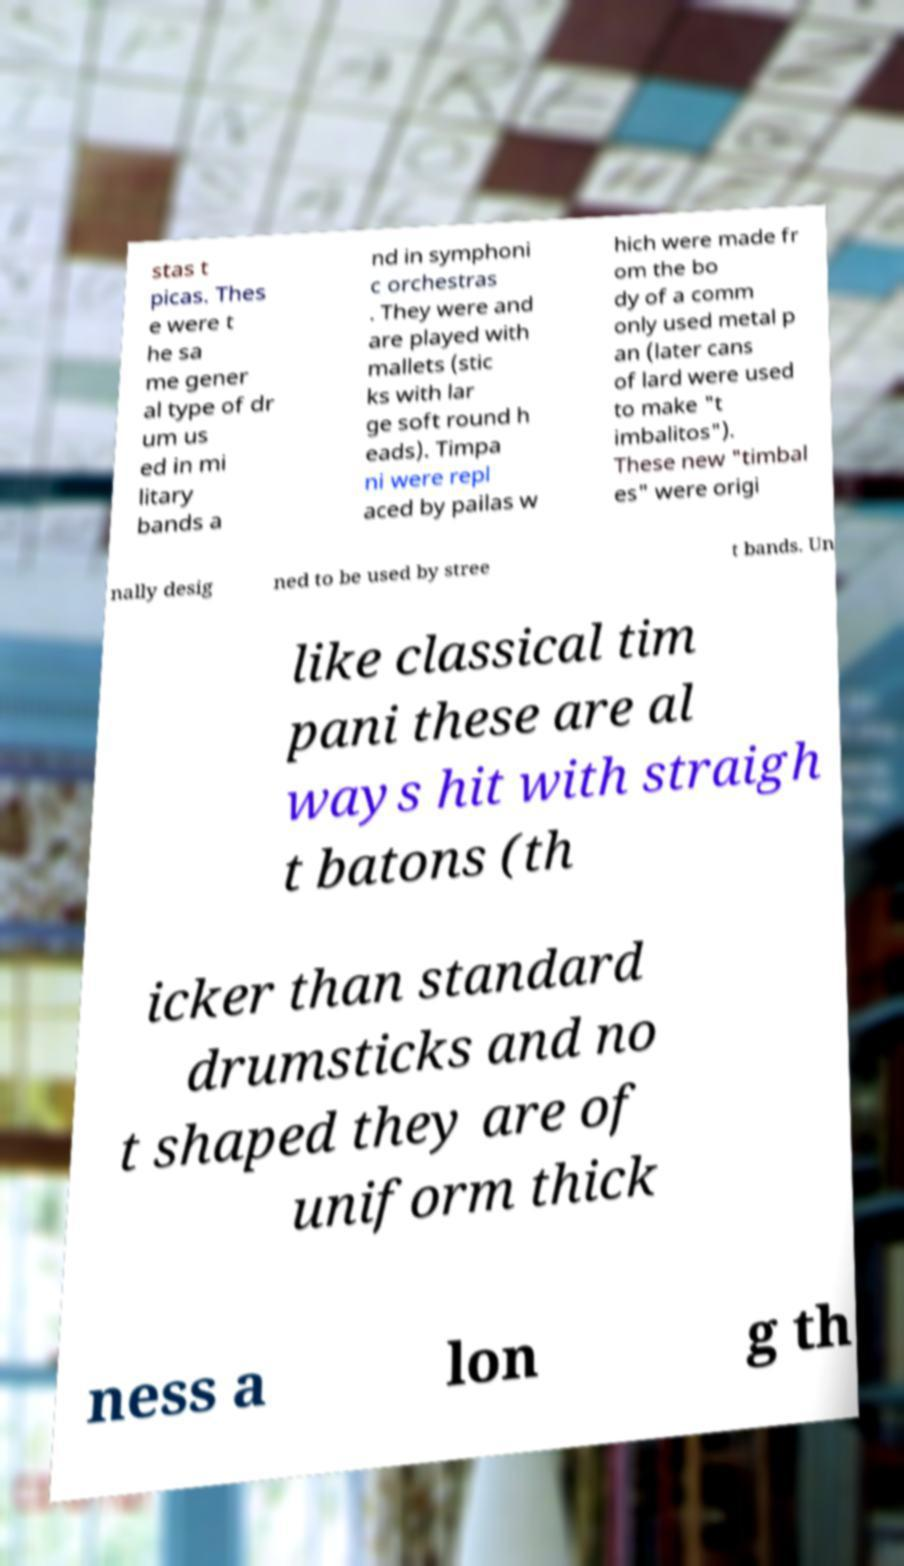Please read and relay the text visible in this image. What does it say? stas t picas. Thes e were t he sa me gener al type of dr um us ed in mi litary bands a nd in symphoni c orchestras . They were and are played with mallets (stic ks with lar ge soft round h eads). Timpa ni were repl aced by pailas w hich were made fr om the bo dy of a comm only used metal p an (later cans of lard were used to make "t imbalitos"). These new "timbal es" were origi nally desig ned to be used by stree t bands. Un like classical tim pani these are al ways hit with straigh t batons (th icker than standard drumsticks and no t shaped they are of uniform thick ness a lon g th 